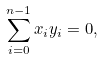<formula> <loc_0><loc_0><loc_500><loc_500>\sum _ { i = 0 } ^ { n - 1 } x _ { i } y _ { i } = 0 ,</formula> 